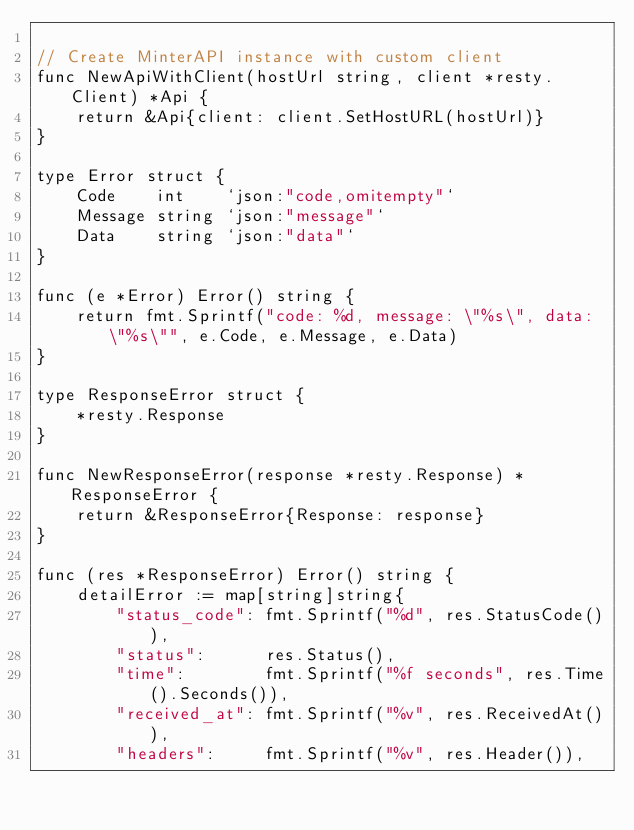<code> <loc_0><loc_0><loc_500><loc_500><_Go_>
// Create MinterAPI instance with custom client
func NewApiWithClient(hostUrl string, client *resty.Client) *Api {
	return &Api{client: client.SetHostURL(hostUrl)}
}

type Error struct {
	Code    int    `json:"code,omitempty"`
	Message string `json:"message"`
	Data    string `json:"data"`
}

func (e *Error) Error() string {
	return fmt.Sprintf("code: %d, message: \"%s\", data: \"%s\"", e.Code, e.Message, e.Data)
}

type ResponseError struct {
	*resty.Response
}

func NewResponseError(response *resty.Response) *ResponseError {
	return &ResponseError{Response: response}
}

func (res *ResponseError) Error() string {
	detailError := map[string]string{
		"status_code": fmt.Sprintf("%d", res.StatusCode()),
		"status":      res.Status(),
		"time":        fmt.Sprintf("%f seconds", res.Time().Seconds()),
		"received_at": fmt.Sprintf("%v", res.ReceivedAt()),
		"headers":     fmt.Sprintf("%v", res.Header()),</code> 